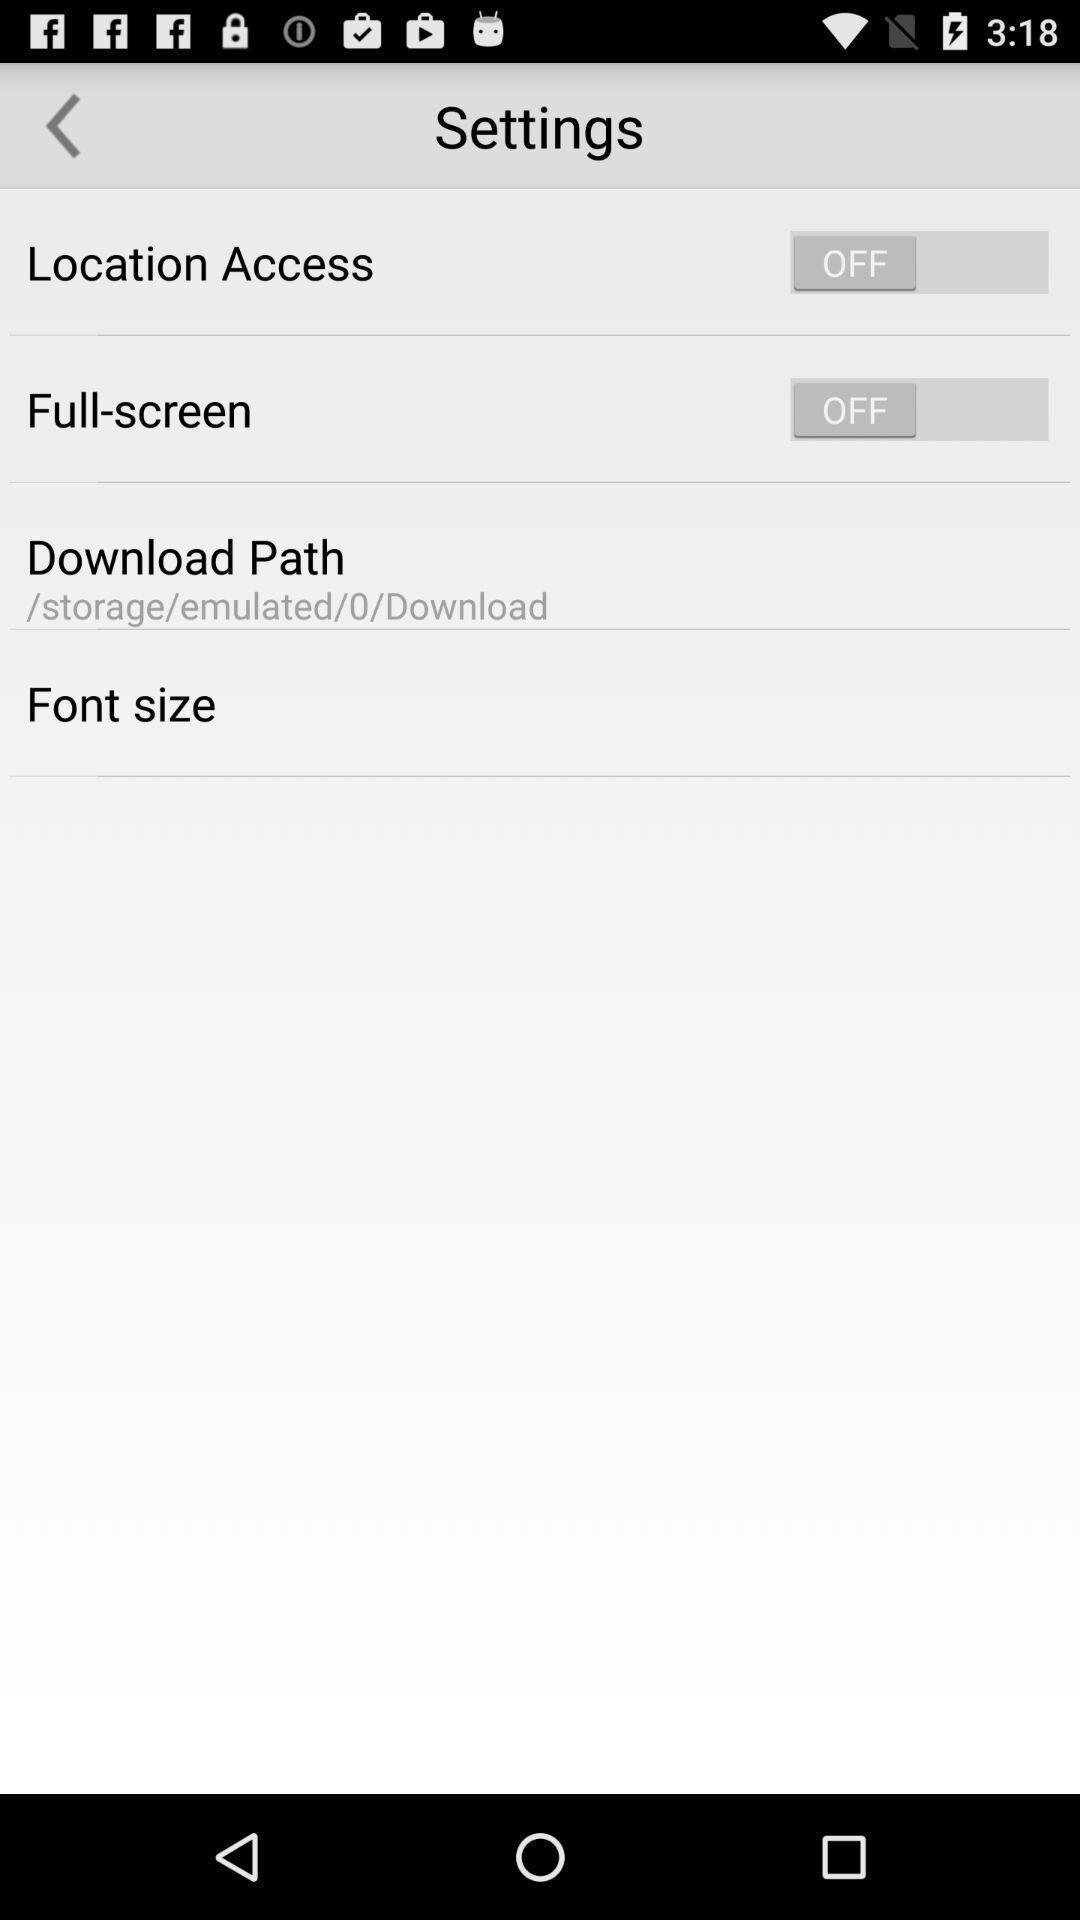Tell me about the visual elements in this screen capture. Settings page. 